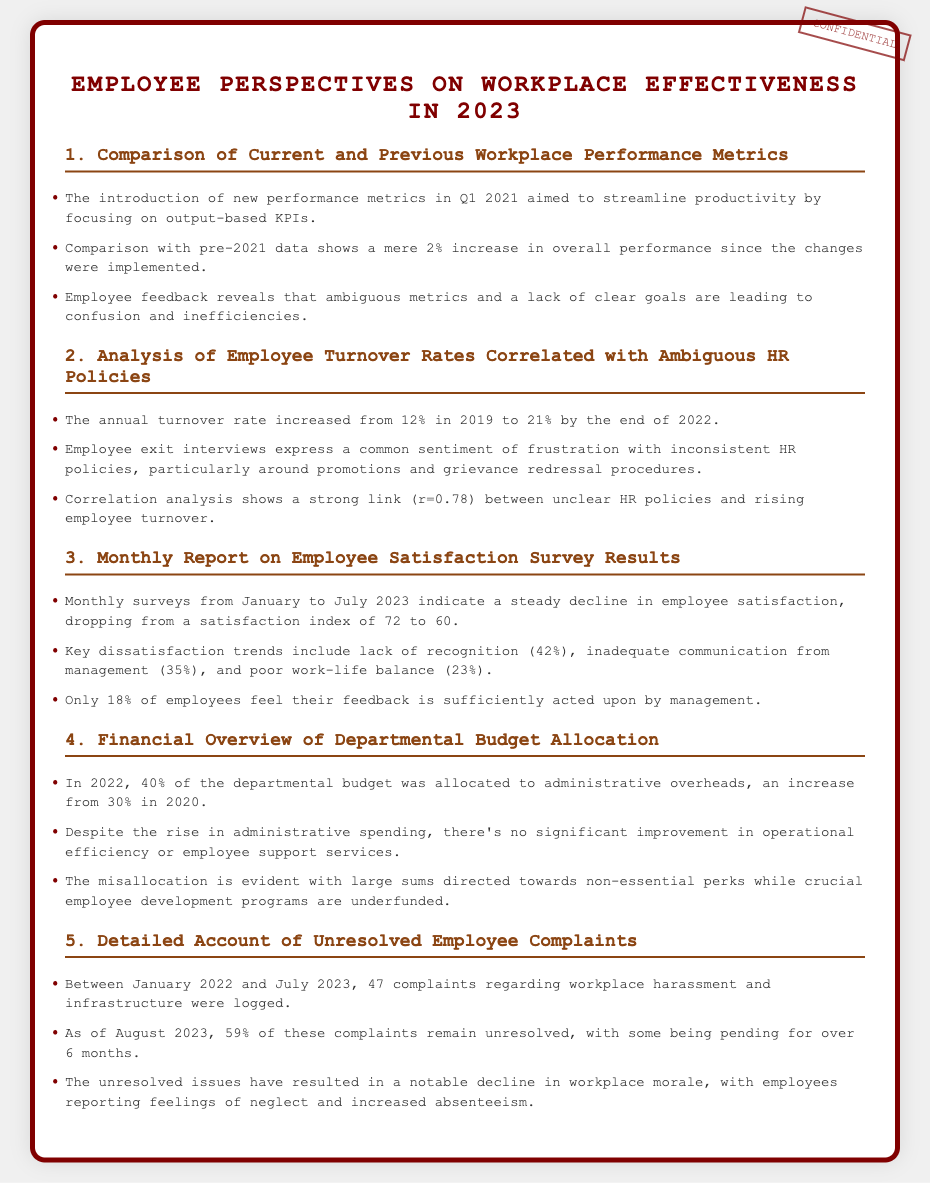What was the performance increase since the new metrics? The document states that there has been a mere 2% increase in overall performance since the changes were implemented.
Answer: 2% What is the annual turnover rate as of the end of 2022? The document indicates that the annual turnover rate increased to 21% by the end of 2022.
Answer: 21% What was the employee satisfaction index in July 2023? According to the document, the satisfaction index dropped to 60 in July 2023.
Answer: 60 What percentage of complaints remained unresolved as of August 2023? The document notes that 59% of these complaints remain unresolved as of August 2023.
Answer: 59% What percentage of the departmental budget was allocated to administrative overheads in 2022? The document states that 40% of the departmental budget was allocated to administrative overheads in 2022.
Answer: 40% What is the correlation coefficient between unclear HR policies and employee turnover? The document shows a strong link with a correlation coefficient of r=0.78.
Answer: r=0.78 What are the top reasons for employee dissatisfaction? The document identifies lack of recognition, inadequate communication, and poor work-life balance as key reasons.
Answer: Lack of recognition, inadequate communication, poor work-life balance How long have some complaints been pending? The document mentions that some complaints have been pending for over 6 months.
Answer: Over 6 months What was the percentage allocated to administrative overheads in 2020? The document states that 30% of the budget was allocated to administrative overheads in 2020.
Answer: 30% 